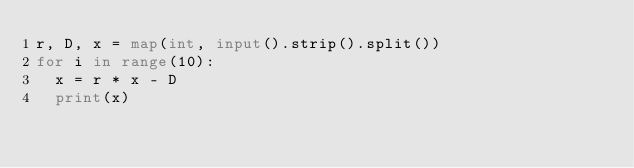<code> <loc_0><loc_0><loc_500><loc_500><_Python_>r, D, x = map(int, input().strip().split())
for i in range(10):
  x = r * x - D
  print(x)</code> 